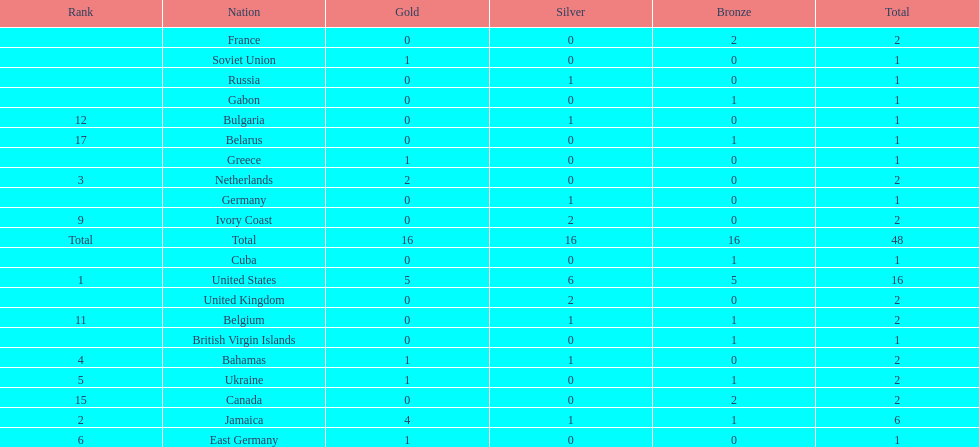Which countries won at least 3 silver medals? United States. 